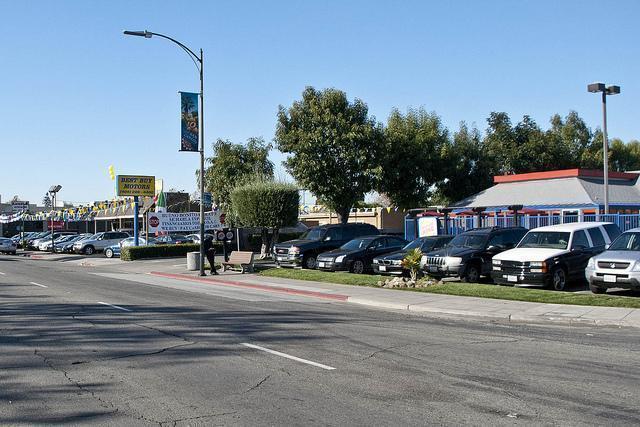What item does the business with banners in front of it sell?
Select the accurate answer and provide justification: `Answer: choice
Rationale: srationale.`
Options: Cars, nothing, car repair, milkshakes. Answer: cars.
Rationale: They have a bunch of cars in their lot 